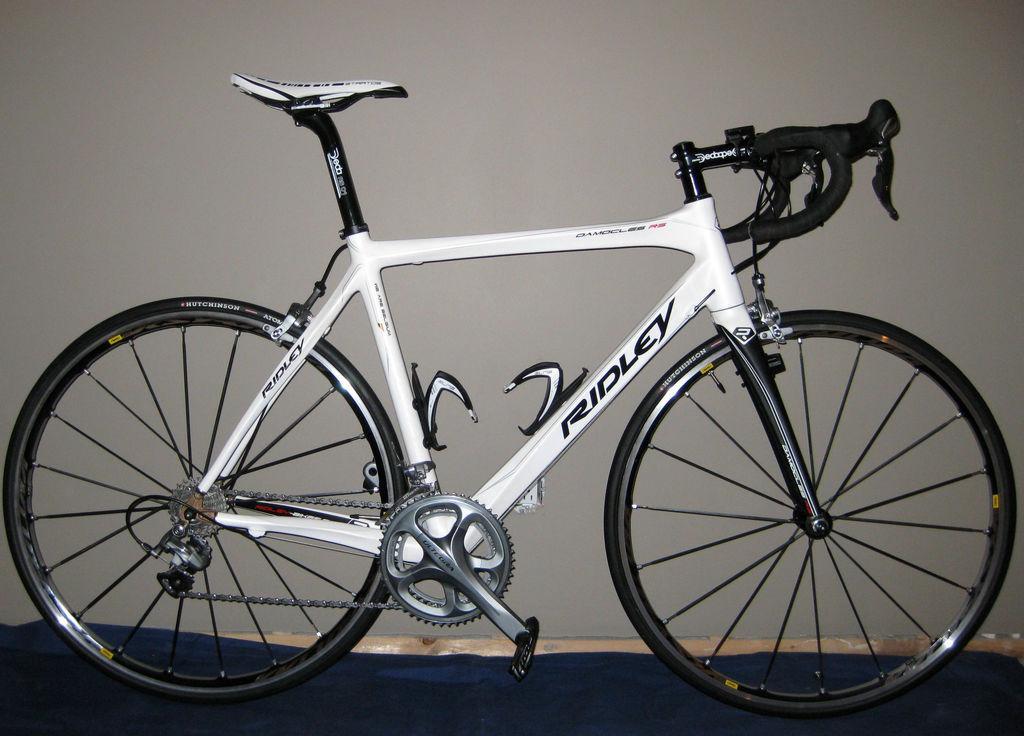Could you give a brief overview of what you see in this image? In this image there is a bicycle placed on the ground. In the background there is a white color board. 